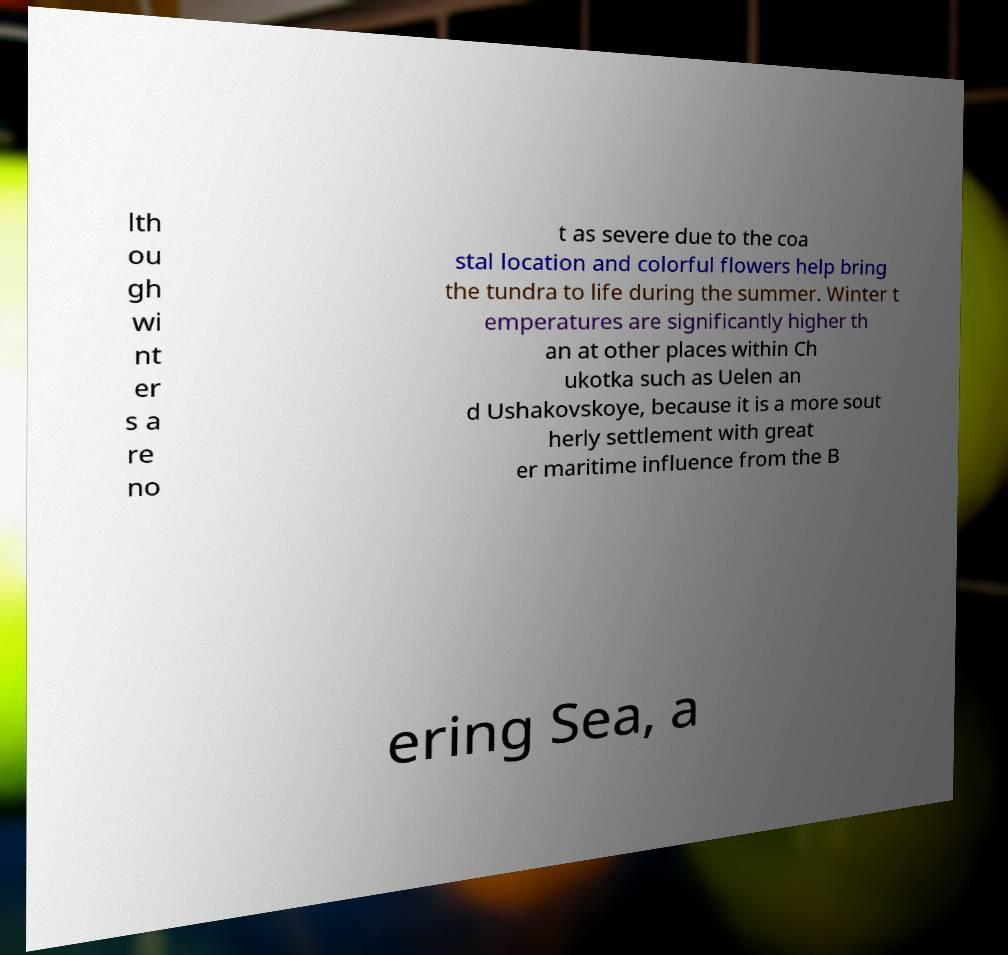Can you read and provide the text displayed in the image?This photo seems to have some interesting text. Can you extract and type it out for me? lth ou gh wi nt er s a re no t as severe due to the coa stal location and colorful flowers help bring the tundra to life during the summer. Winter t emperatures are significantly higher th an at other places within Ch ukotka such as Uelen an d Ushakovskoye, because it is a more sout herly settlement with great er maritime influence from the B ering Sea, a 